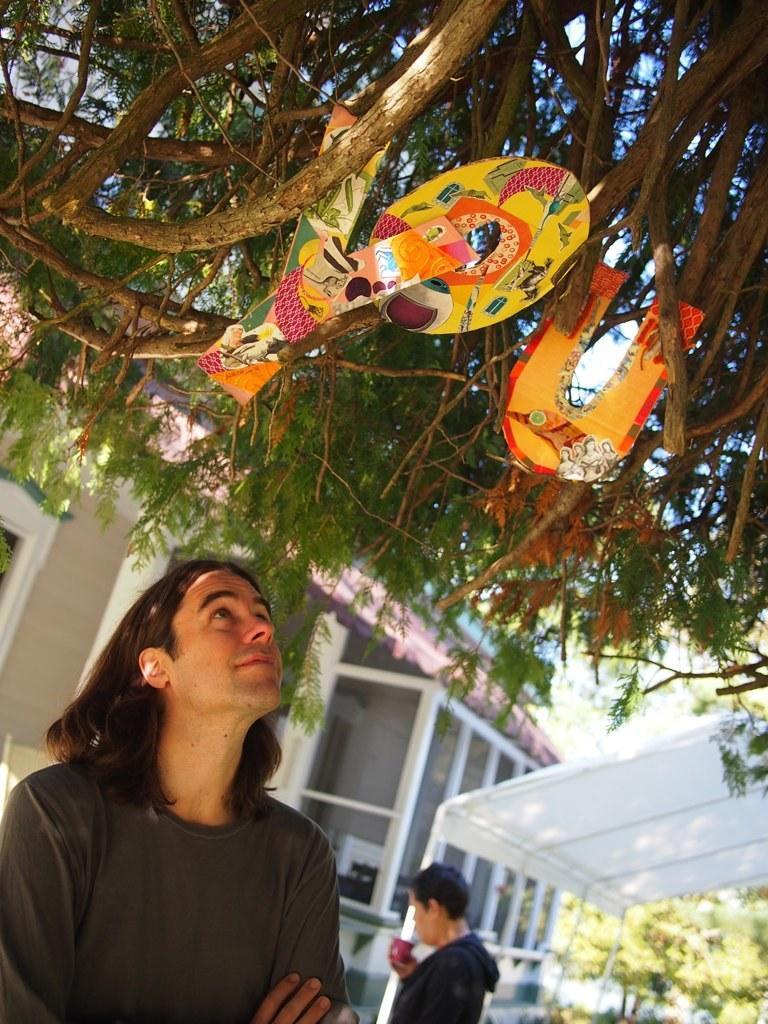Can you describe this image briefly? The man in the bottom of the picture wearing black t-shirt is looking at the alphabet placed on the tree. Beside him, the man in black jacket is holding a cup in his hand. Beside her, we see a tent in white color. There are trees and buildings in the background. 